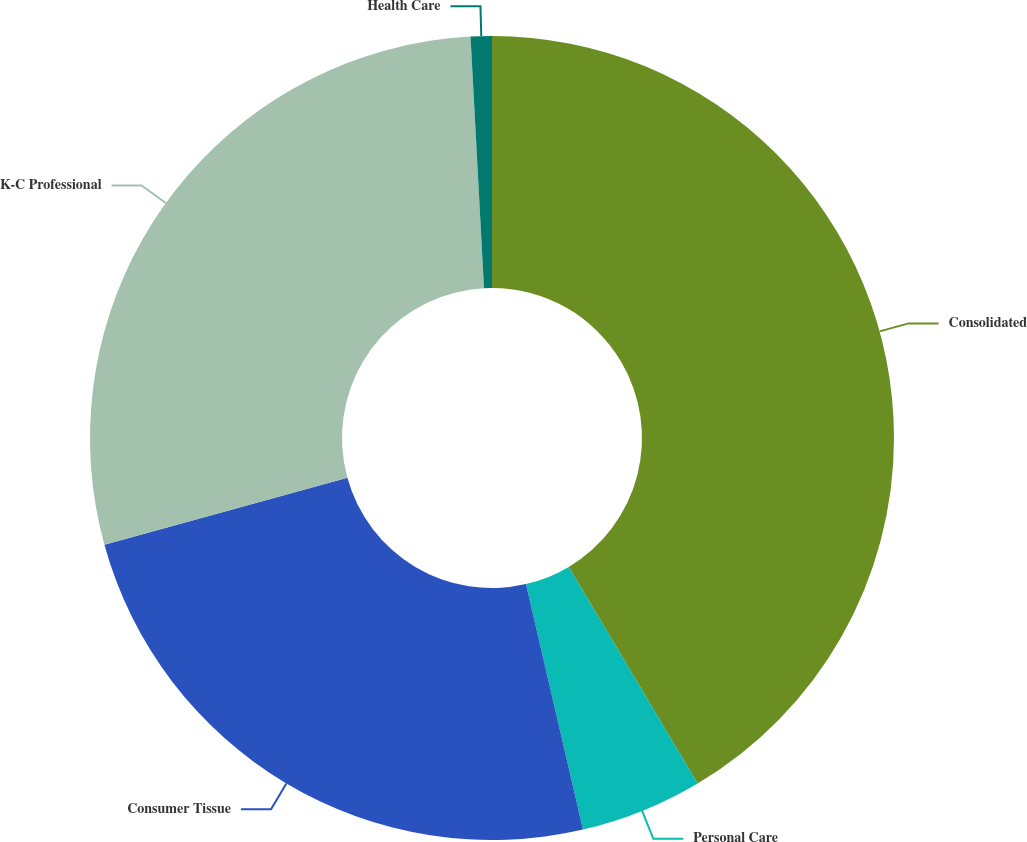Convert chart. <chart><loc_0><loc_0><loc_500><loc_500><pie_chart><fcel>Consolidated<fcel>Personal Care<fcel>Consumer Tissue<fcel>K-C Professional<fcel>Health Care<nl><fcel>41.45%<fcel>4.91%<fcel>24.36%<fcel>28.42%<fcel>0.85%<nl></chart> 